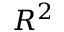Convert formula to latex. <formula><loc_0><loc_0><loc_500><loc_500>R ^ { 2 }</formula> 